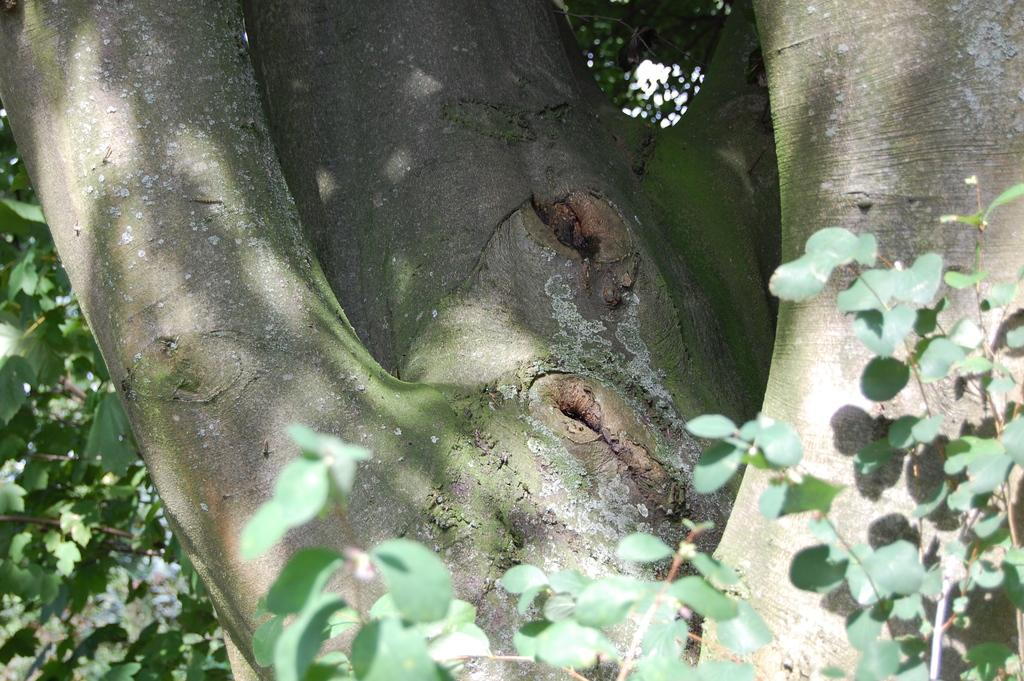What part of a tree is visible in the image? There is a bark of a tree in the image. What else can be seen on the tree in the image? There are leaves in the image. What type of juice can be seen dripping from the leaves in the image? There is no juice present in the image; it only features the bark of a tree and leaves. 